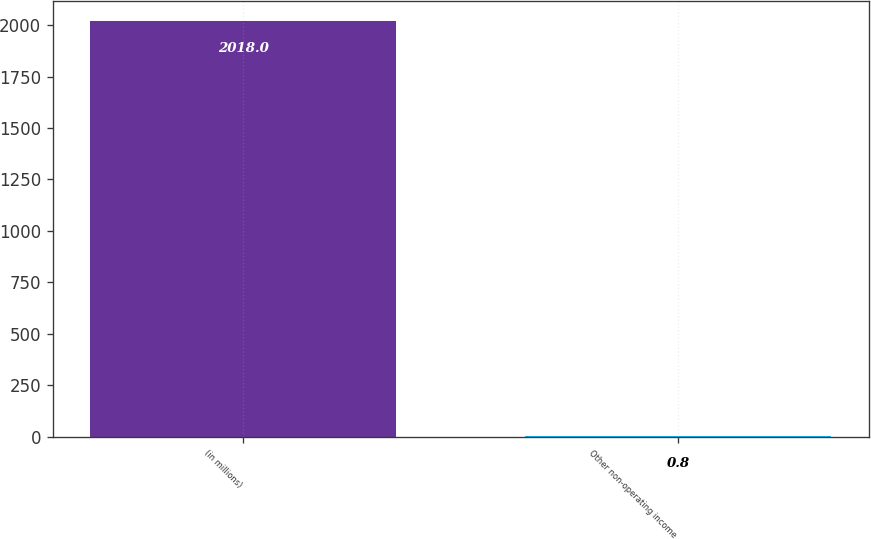Convert chart. <chart><loc_0><loc_0><loc_500><loc_500><bar_chart><fcel>(in millions)<fcel>Other non-operating income<nl><fcel>2018<fcel>0.8<nl></chart> 